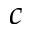<formula> <loc_0><loc_0><loc_500><loc_500>c</formula> 